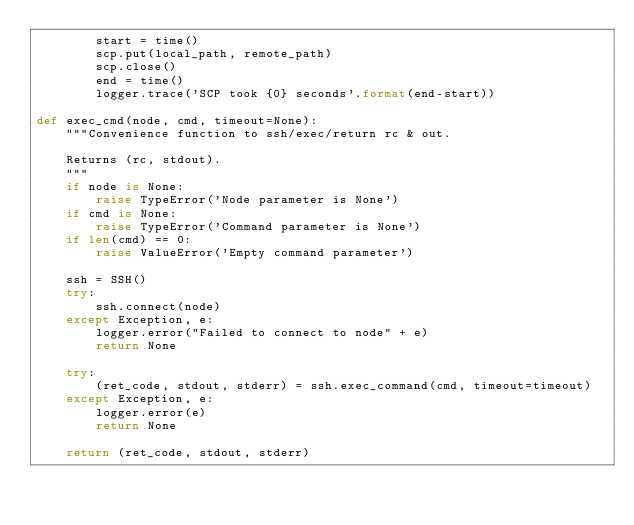Convert code to text. <code><loc_0><loc_0><loc_500><loc_500><_Python_>        start = time()
        scp.put(local_path, remote_path)
        scp.close()
        end = time()
        logger.trace('SCP took {0} seconds'.format(end-start))

def exec_cmd(node, cmd, timeout=None):
    """Convenience function to ssh/exec/return rc & out.

    Returns (rc, stdout).
    """
    if node is None:
        raise TypeError('Node parameter is None')
    if cmd is None:
        raise TypeError('Command parameter is None')
    if len(cmd) == 0:
        raise ValueError('Empty command parameter')

    ssh = SSH()
    try:
        ssh.connect(node)
    except Exception, e:
        logger.error("Failed to connect to node" + e)
        return None

    try:
        (ret_code, stdout, stderr) = ssh.exec_command(cmd, timeout=timeout)
    except Exception, e:
        logger.error(e)
        return None

    return (ret_code, stdout, stderr)

</code> 